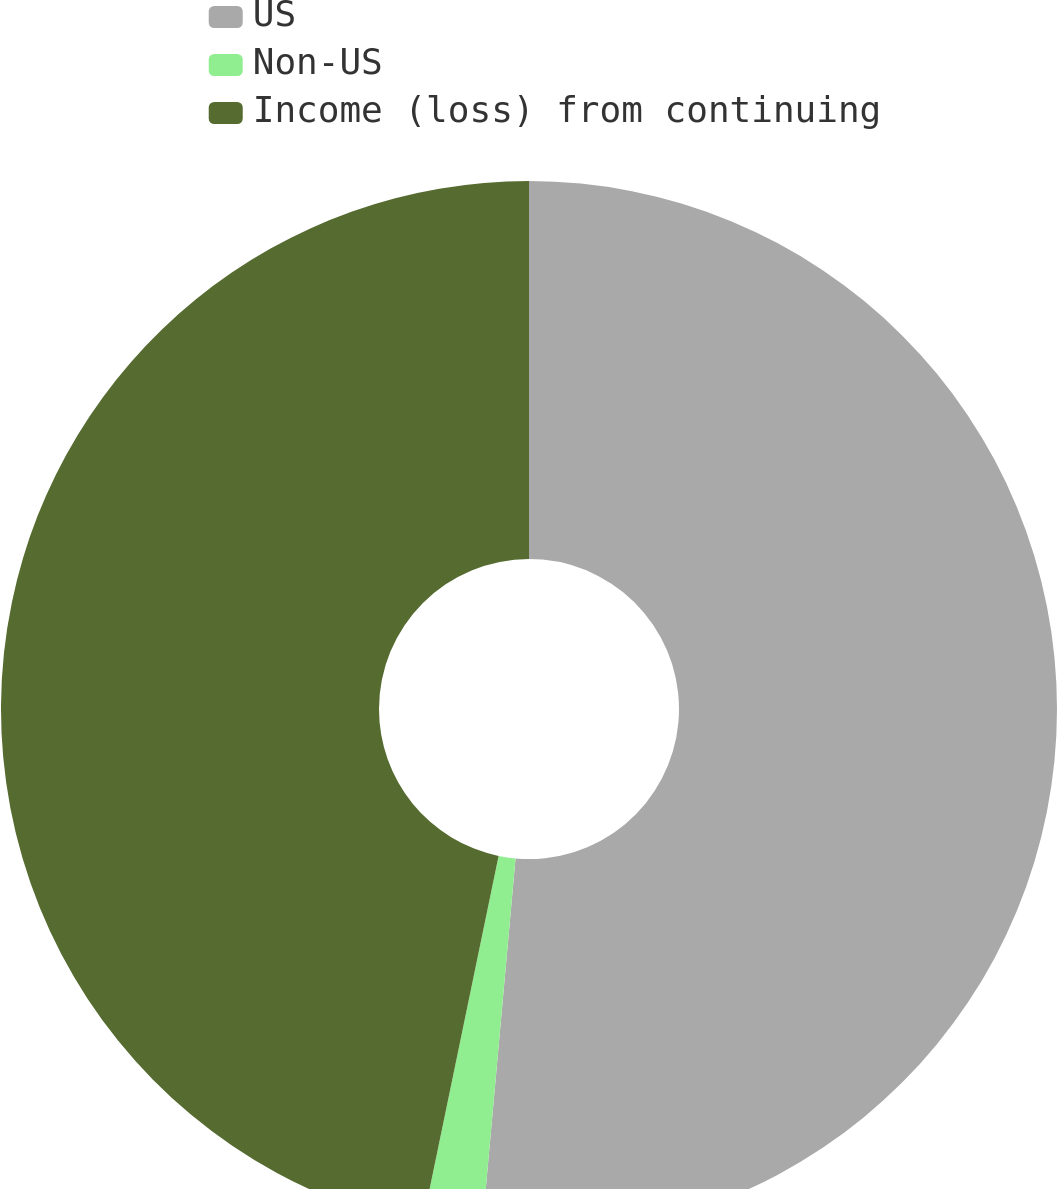Convert chart to OTSL. <chart><loc_0><loc_0><loc_500><loc_500><pie_chart><fcel>US<fcel>Non-US<fcel>Income (loss) from continuing<nl><fcel>51.43%<fcel>1.82%<fcel>46.75%<nl></chart> 